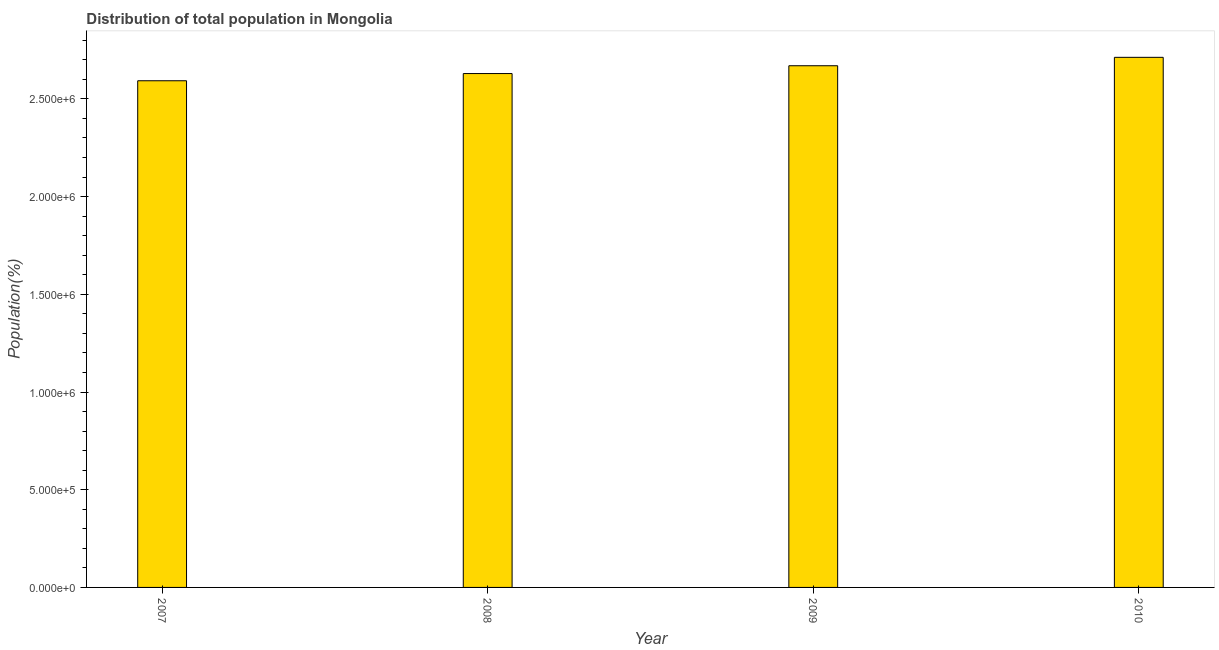Does the graph contain grids?
Your answer should be compact. No. What is the title of the graph?
Keep it short and to the point. Distribution of total population in Mongolia . What is the label or title of the Y-axis?
Your answer should be very brief. Population(%). What is the population in 2007?
Your answer should be very brief. 2.59e+06. Across all years, what is the maximum population?
Your answer should be very brief. 2.71e+06. Across all years, what is the minimum population?
Make the answer very short. 2.59e+06. In which year was the population maximum?
Give a very brief answer. 2010. In which year was the population minimum?
Provide a succinct answer. 2007. What is the sum of the population?
Make the answer very short. 1.06e+07. What is the difference between the population in 2008 and 2010?
Keep it short and to the point. -8.30e+04. What is the average population per year?
Your response must be concise. 2.65e+06. What is the median population?
Give a very brief answer. 2.65e+06. In how many years, is the population greater than 1500000 %?
Your answer should be very brief. 4. What is the ratio of the population in 2007 to that in 2009?
Keep it short and to the point. 0.97. Is the population in 2008 less than that in 2010?
Ensure brevity in your answer.  Yes. Is the difference between the population in 2007 and 2008 greater than the difference between any two years?
Provide a short and direct response. No. What is the difference between the highest and the second highest population?
Keep it short and to the point. 4.31e+04. What is the difference between the highest and the lowest population?
Your answer should be compact. 1.20e+05. What is the Population(%) of 2007?
Give a very brief answer. 2.59e+06. What is the Population(%) of 2008?
Your answer should be compact. 2.63e+06. What is the Population(%) of 2009?
Your answer should be compact. 2.67e+06. What is the Population(%) of 2010?
Your response must be concise. 2.71e+06. What is the difference between the Population(%) in 2007 and 2008?
Provide a succinct answer. -3.69e+04. What is the difference between the Population(%) in 2007 and 2009?
Provide a short and direct response. -7.68e+04. What is the difference between the Population(%) in 2007 and 2010?
Your response must be concise. -1.20e+05. What is the difference between the Population(%) in 2008 and 2009?
Provide a succinct answer. -3.99e+04. What is the difference between the Population(%) in 2008 and 2010?
Provide a short and direct response. -8.30e+04. What is the difference between the Population(%) in 2009 and 2010?
Make the answer very short. -4.31e+04. What is the ratio of the Population(%) in 2007 to that in 2010?
Provide a succinct answer. 0.96. What is the ratio of the Population(%) in 2008 to that in 2009?
Offer a very short reply. 0.98. What is the ratio of the Population(%) in 2008 to that in 2010?
Your answer should be compact. 0.97. 